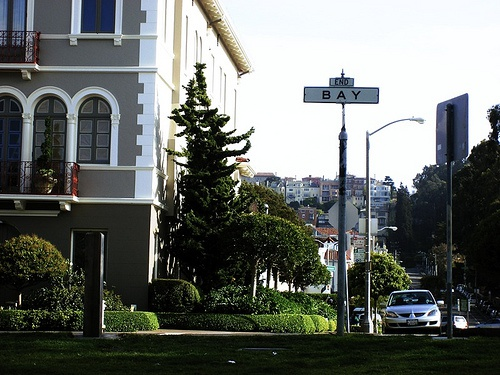Describe the objects in this image and their specific colors. I can see car in gray, black, white, and lightblue tones, stop sign in gray tones, and car in gray, white, black, darkgray, and navy tones in this image. 